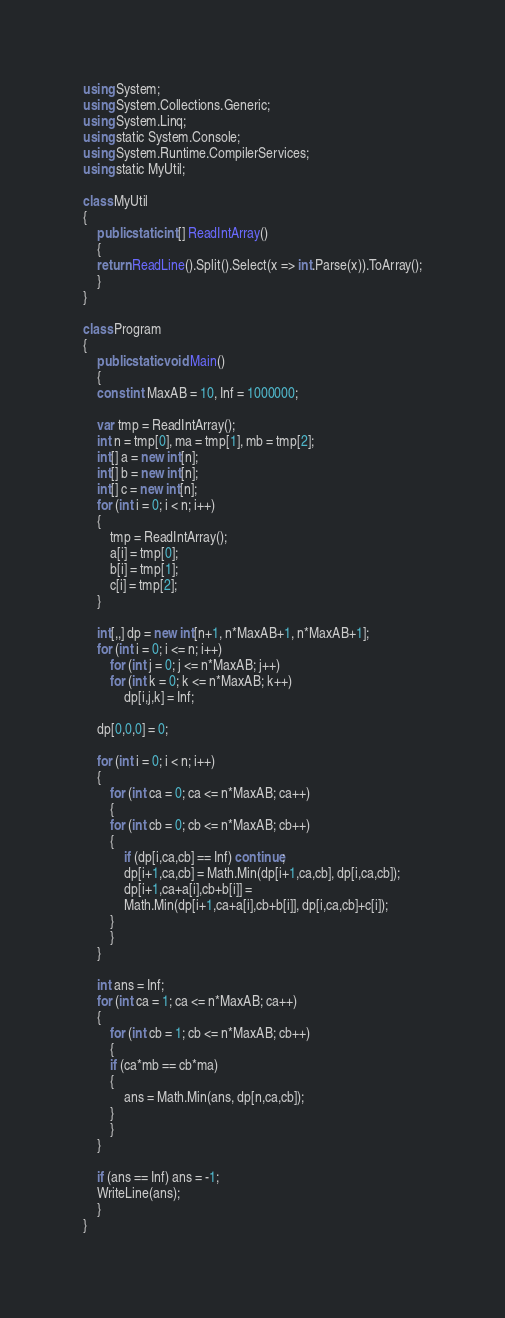<code> <loc_0><loc_0><loc_500><loc_500><_C#_>using System;
using System.Collections.Generic;
using System.Linq;
using static System.Console;
using System.Runtime.CompilerServices;
using static MyUtil;

class MyUtil
{
    public static int[] ReadIntArray()
    {
	return ReadLine().Split().Select(x => int.Parse(x)).ToArray();
    }
}

class Program
{
    public static void Main()
    {
	const int MaxAB = 10, Inf = 1000000;
	
	var tmp = ReadIntArray();
	int n = tmp[0], ma = tmp[1], mb = tmp[2];
	int[] a = new int[n];
	int[] b = new int[n];
	int[] c = new int[n];
	for (int i = 0; i < n; i++)
	{
	    tmp = ReadIntArray();
	    a[i] = tmp[0];
	    b[i] = tmp[1];
	    c[i] = tmp[2];
	}

	int[,,] dp = new int[n+1, n*MaxAB+1, n*MaxAB+1];
	for (int i = 0; i <= n; i++)
	    for (int j = 0; j <= n*MaxAB; j++)
		for (int k = 0; k <= n*MaxAB; k++)
		    dp[i,j,k] = Inf;

	dp[0,0,0] = 0;

	for (int i = 0; i < n; i++)
	{
	    for (int ca = 0; ca <= n*MaxAB; ca++)
	    {
		for (int cb = 0; cb <= n*MaxAB; cb++)
		{
		    if (dp[i,ca,cb] == Inf) continue;
		    dp[i+1,ca,cb] = Math.Min(dp[i+1,ca,cb], dp[i,ca,cb]);
		    dp[i+1,ca+a[i],cb+b[i]] =
			Math.Min(dp[i+1,ca+a[i],cb+b[i]], dp[i,ca,cb]+c[i]);
		}
	    }
	}

	int ans = Inf;
	for (int ca = 1; ca <= n*MaxAB; ca++)
	{
	    for (int cb = 1; cb <= n*MaxAB; cb++)
	    {
		if (ca*mb == cb*ma)
		{
		    ans = Math.Min(ans, dp[n,ca,cb]);
		}
	    }
	}

	if (ans == Inf) ans = -1;
	WriteLine(ans);
    }
}
</code> 